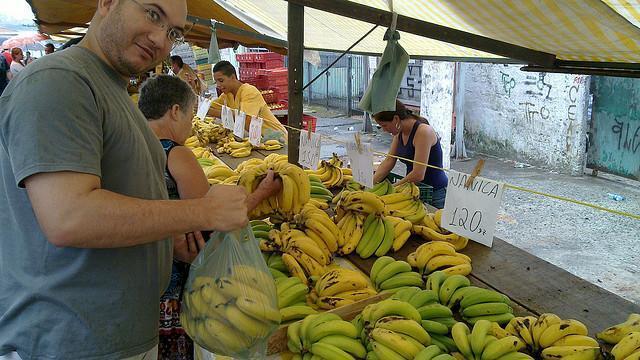How many groups of bananas are hanging?
Give a very brief answer. 0. How many different fruits do you see?
Give a very brief answer. 1. How many bananas are there?
Give a very brief answer. 6. How many people are there?
Give a very brief answer. 4. 